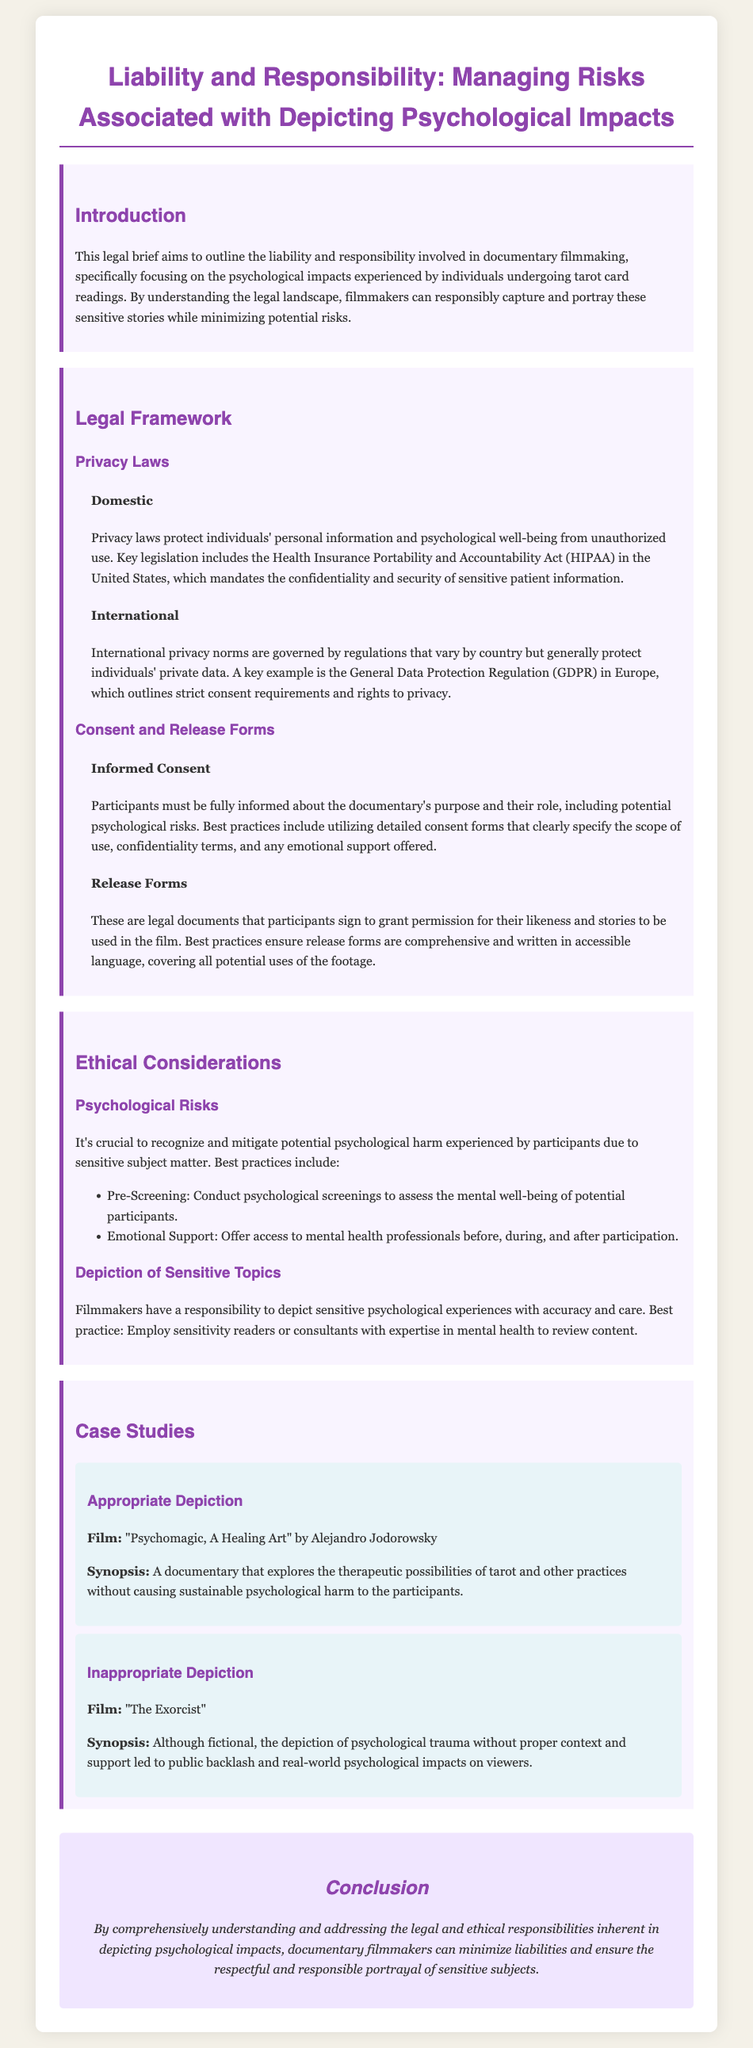What is the title of the legal brief? The title appears at the top of the document under the header section.
Answer: Liability and Responsibility: Managing Risks Associated with Depicting Psychological Impacts What is the main aim of this legal brief? The main aim is outlined in the introduction section of the document.
Answer: To outline the liability and responsibility involved in documentary filmmaking What act is mentioned that mandates confidentiality of sensitive patient information? This act is specified in the Privacy Laws subsection under Domestic regulations.
Answer: Health Insurance Portability and Accountability Act (HIPAA) What international regulation is highlighted for protecting private data? This regulation is addressed in the International privacy norms subsection.
Answer: General Data Protection Regulation (GDPR) What psychological support is suggested for participants? The recommendation for support is listed under Ethical Considerations.
Answer: Access to mental health professionals Who directed the film "Psychomagic, A Healing Art"? This information can be found in the case studies section.
Answer: Alejandro Jodorowsky What is a potential risk in depicting psychological experiences? This risk is mentioned in the Ethical Considerations section under Psychological Risks.
Answer: Psychological harm Which document should participants sign to grant permission for their likeness and stories? This is discussed under the Consent and Release Forms section.
Answer: Release forms What is suggested to ensure the accurate depiction of sensitive topics? This best practice is outlined in the Ethical Considerations section under Depiction of Sensitive Topics.
Answer: Employ sensitivity readers or consultants 